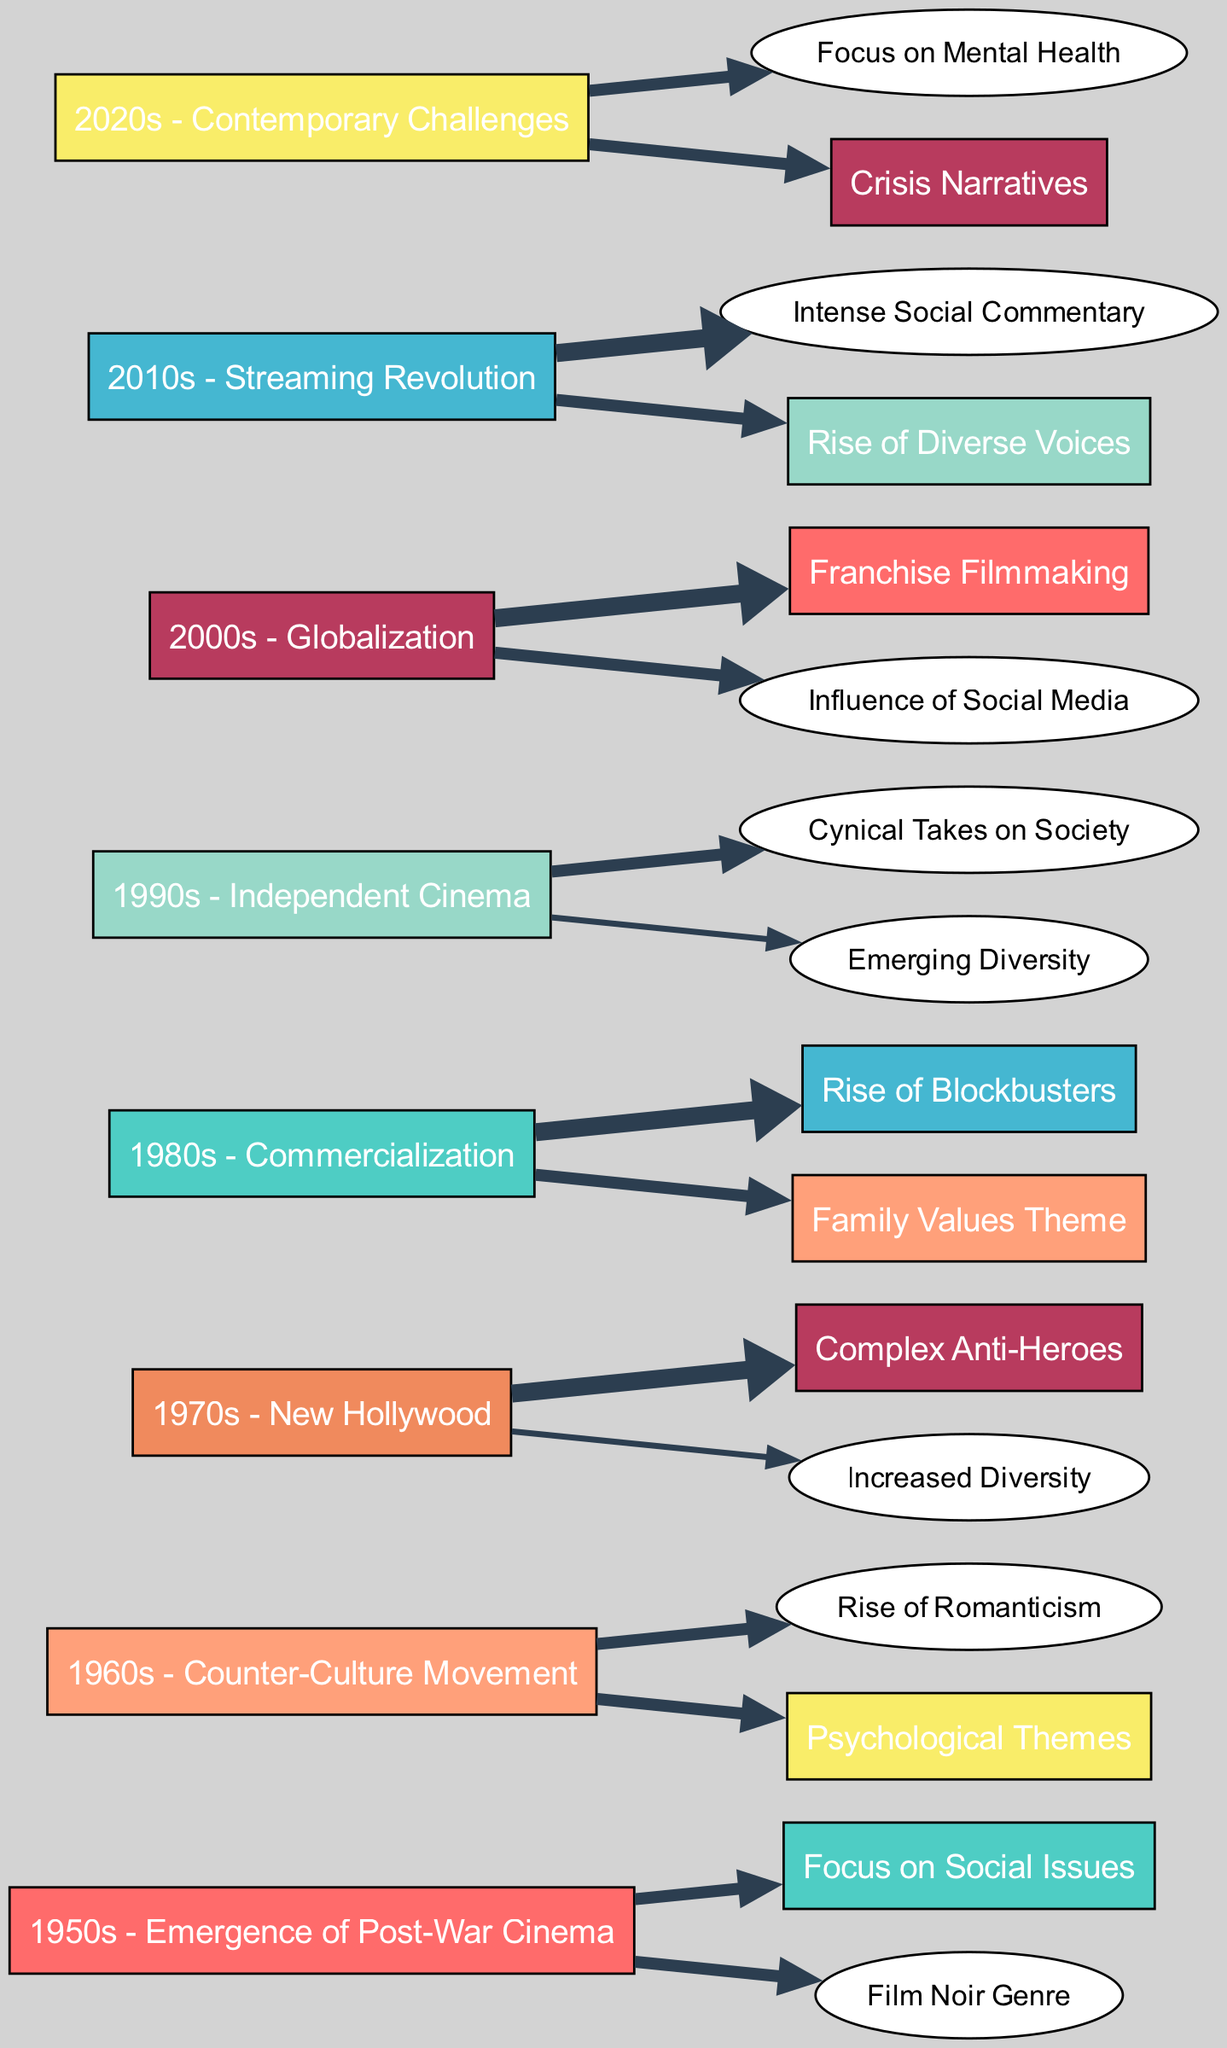What themes stemmed from the 1950s? The diagram shows that the 1950s connects to the themes "Focus on Social Issues" and "Film Noir Genre," each with a value of 10.
Answer: Focus on Social Issues, Film Noir Genre Which decade illustrates the rise of complex anti-heroes? From the Sankey Diagram, the 1970s is linked to the theme "Complex Anti-Heroes" with the highest value of 15.
Answer: 1970s How many total themes are represented in the diagram? By counting the individual theme nodes presented, there are 13 distinct themes throughout the decades.
Answer: 13 What narrative theme has the highest flow in the 1980s? The data shows that the highest value originating from the 1980s is the theme "Rise of Blockbusters," with a value of 15.
Answer: Rise of Blockbusters Which theme is tied to the highest number of sources? The themes "Social Issues" and "Crisis Narratives" each have links from different decades, indicating they draw from multiple temporal sources, with four and three, respectively.
Answer: Social Issues What trends can be observed in the 2010s compared to the 2000s? In the 2010s, there is an emphasis on "Social Commentary" and "Diverse Voices," while the 2000s focused on "Franchises" and "Social Media," showing a shift from entertainment-centric themes to social themes.
Answer: Shift to social themes How does the focus on mental health in the 2020s compare to previous decades? The focus on "Mental Health," linked from the 2020s, reflects a growing concern for psychological elements, which is a more contemporary theme not directly found in earlier decades, which tended to focus on societal themes.
Answer: Growing concern Which decade showed an increased emphasis on diversity? The theme "Increased Diversity" is connected to the 1970s but later evolves into "Diversity in Representation" in the 1990s, showing a trend toward recognizing and promoting diverse narratives.
Answer: 1970s to 1990s What are the two main themes emerging in the 2020s? The 2020s are notably linked to the themes "Focus on Mental Health" and "Crisis Narratives," each showing a value of 10, reflecting urgency in contemporary storytelling.
Answer: Focus on Mental Health, Crisis Narratives 